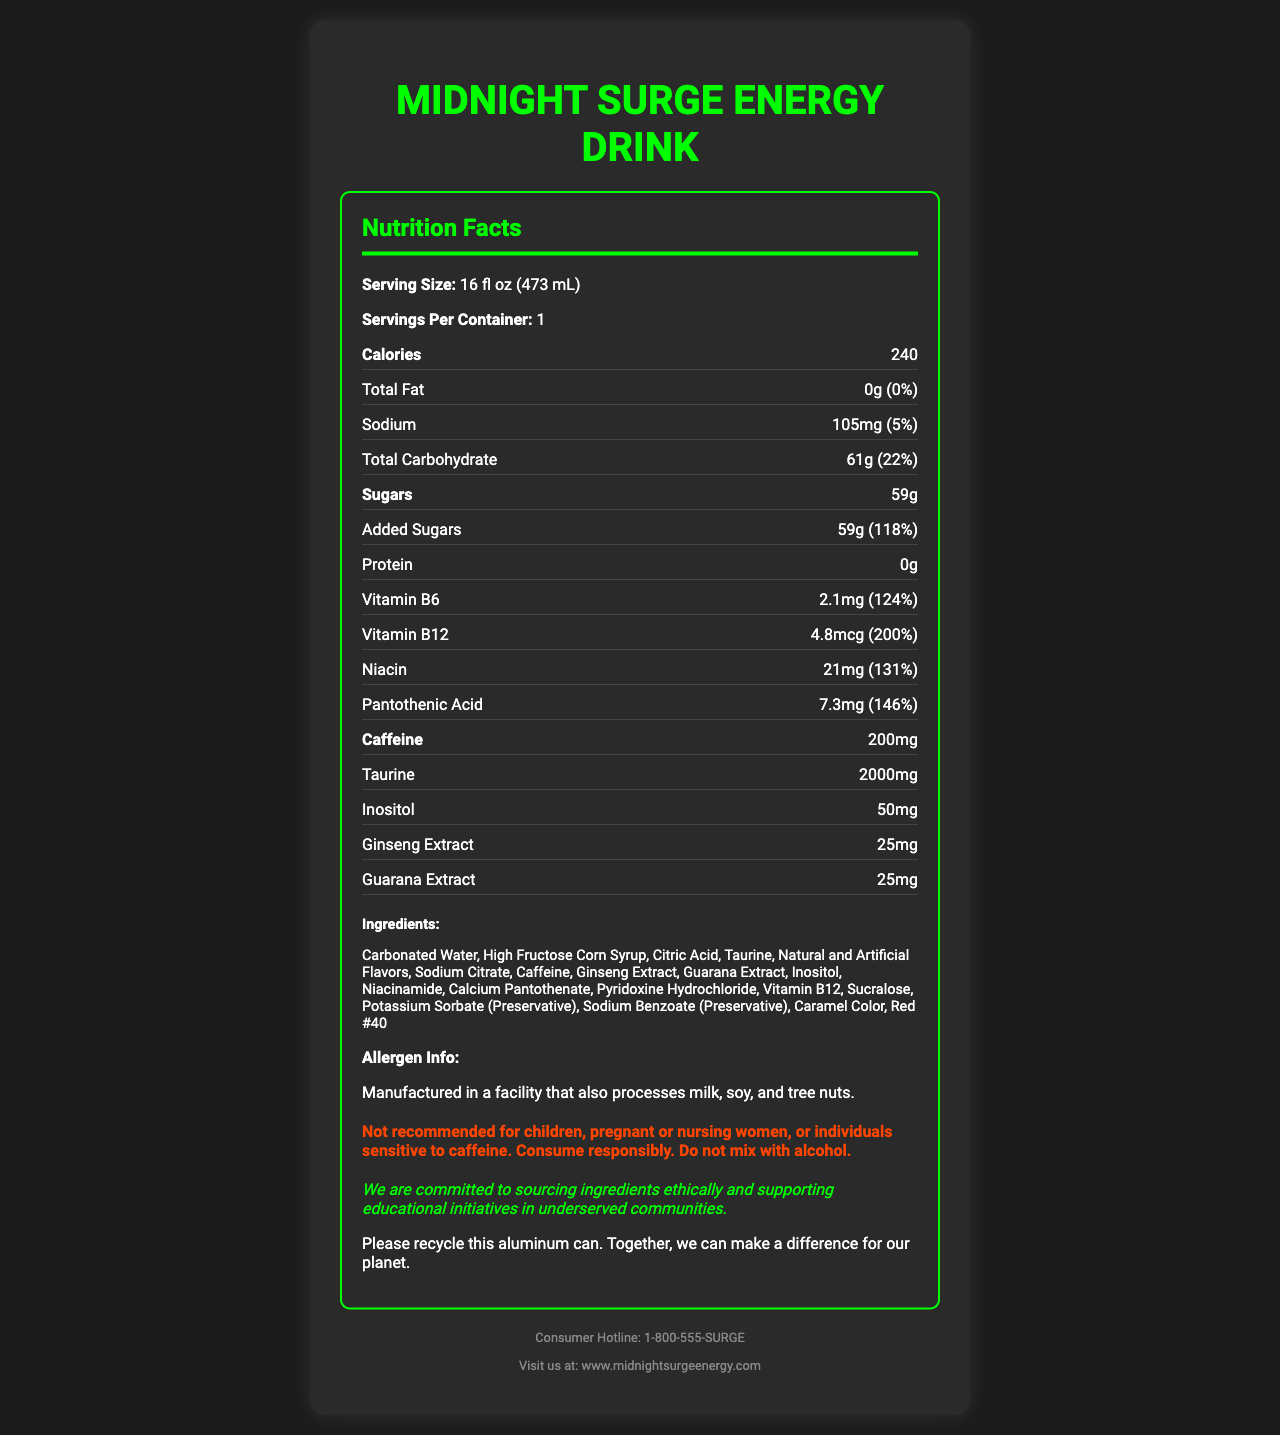what is the serving size of the drink? The serving size is explicitly mentioned as "16 fl oz (473 mL)" under the Nutrition Facts.
Answer: 16 fl oz (473 mL) how many calories are there per serving? The label lists "240" as the number of calories per serving.
Answer: 240 calories what percentage of the daily value is the total carbohydrate? The total carbohydrate content is 61g, which is 22% of the daily value.
Answer: 22% how much caffeine does the Midnight Surge Energy Drink contain? The nutrition section lists caffeine as having 200mg.
Answer: 200mg what is the sodium content in milligrams and percentage of daily value? The sodium content is listed as "105mg (5%)" under the Nutrition Facts.
Answer: 105mg (5%) What is the total sugar content in the energy drink? A. 59g B. 61g C. 200mg D. 105mg Total sugars are listed as 59g under the Nutrition Facts section.
Answer: A. 59g What vitamin has the highest daily value percentage in the Midnight Surge Energy Drink? i. Vitamin B6 ii. Vitamin B12 iii. Niacin iv. Pantothenic Acid Vitamin B12 has a daily value percentage of 200%, the highest among the listed vitamins.
Answer: ii. Vitamin B12 does the drink have any protein? The Nutrition Facts label lists "Protein: 0g," indicating there is no protein in the drink.
Answer: No is this energy drink recommended for children? The warning section explicitly states, "Not recommended for children."
Answer: No summarize the main nutritional components of the Midnight Surge Energy Drink. The document provides detailed nutritional information, including calorie content, macronutrients, vitamins, caffeine, and other additional ingredients, along with warnings and social responsibility statements.
Answer: The Midnight Surge Energy Drink contains 240 calories per 16 fl oz serving, with 0g of total fat, 105mg of sodium, 61g of total carbohydrate, 59g of sugars (including added sugars), and 0g of protein. It also contains 200mg of caffeine, vitamins B6 (2.1mg), B12 (4.8mcg), niacin (21mg), pantothenic acid (7.3mg), and other ingredients such as taurine, inositol, and extracts of ginseng and guarana. who manufactures the Midnight Surge Energy Drink? The document does not provide specifics on the manufacturer name, only details about the product itself.
Answer: Not enough information what are the main sweeteners used in the drink? The ingredients list includes "High Fructose Corn Syrup" and "Sucralose" as the main sweeteners.
Answer: High Fructose Corn Syrup, Sucralose how much taurine is in the energy drink? The nutrition section lists taurine with a content of 2000mg.
Answer: 2000mg does the energy drink support any social initiatives? The social responsibility section mentions that the company supports educational initiatives in underserved communities.
Answer: Yes what is the color additive used in the energy drink? Among the ingredients, "Red #40" is listed as a color additive.
Answer: Red #40 how is the energy drink packaged regarding environmental impact? The recycling info section explicitly states, "Please recycle this aluminum can."
Answer: The drink is in an aluminum can that should be recycled what allergens are processed in the facility that manufactures the drink? The allergen information mentions that the facility also processes milk, soy, and tree nuts.
Answer: Milk, soy, and tree nuts 